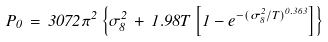<formula> <loc_0><loc_0><loc_500><loc_500>P _ { 0 } \, = \, 3 0 7 2 \pi ^ { 2 } \left \{ \sigma _ { 8 } ^ { 2 } \, + \, 1 . 9 8 T \left [ 1 - e ^ { - ( \sigma _ { 8 } ^ { 2 } / T ) ^ { 0 . 3 6 3 } } \right ] \right \}</formula> 